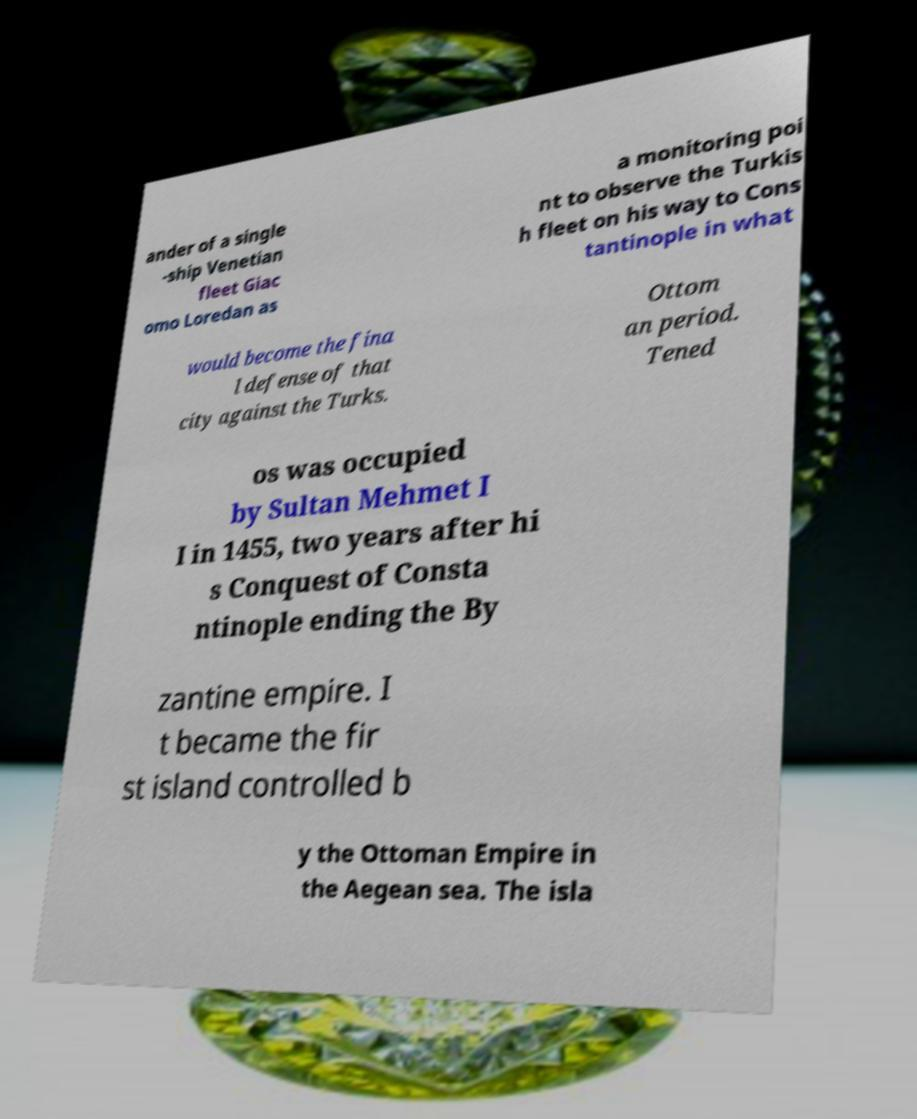Can you accurately transcribe the text from the provided image for me? ander of a single -ship Venetian fleet Giac omo Loredan as a monitoring poi nt to observe the Turkis h fleet on his way to Cons tantinople in what would become the fina l defense of that city against the Turks. Ottom an period. Tened os was occupied by Sultan Mehmet I I in 1455, two years after hi s Conquest of Consta ntinople ending the By zantine empire. I t became the fir st island controlled b y the Ottoman Empire in the Aegean sea. The isla 